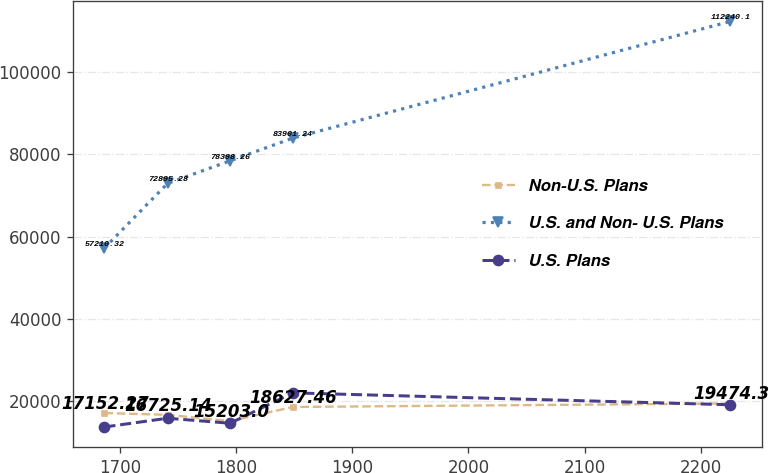Convert chart. <chart><loc_0><loc_0><loc_500><loc_500><line_chart><ecel><fcel>Non-U.S. Plans<fcel>U.S. and Non- U.S. Plans<fcel>U.S. Plans<nl><fcel>1686.75<fcel>17152.3<fcel>57210.3<fcel>13765.1<nl><fcel>1741.1<fcel>16725.1<fcel>72895.3<fcel>15894.9<nl><fcel>1794.96<fcel>15203<fcel>78398.3<fcel>14676.7<nl><fcel>1848.82<fcel>18627.5<fcel>83901.2<fcel>22052<nl><fcel>2225.33<fcel>19474.3<fcel>112240<fcel>19164.5<nl></chart> 